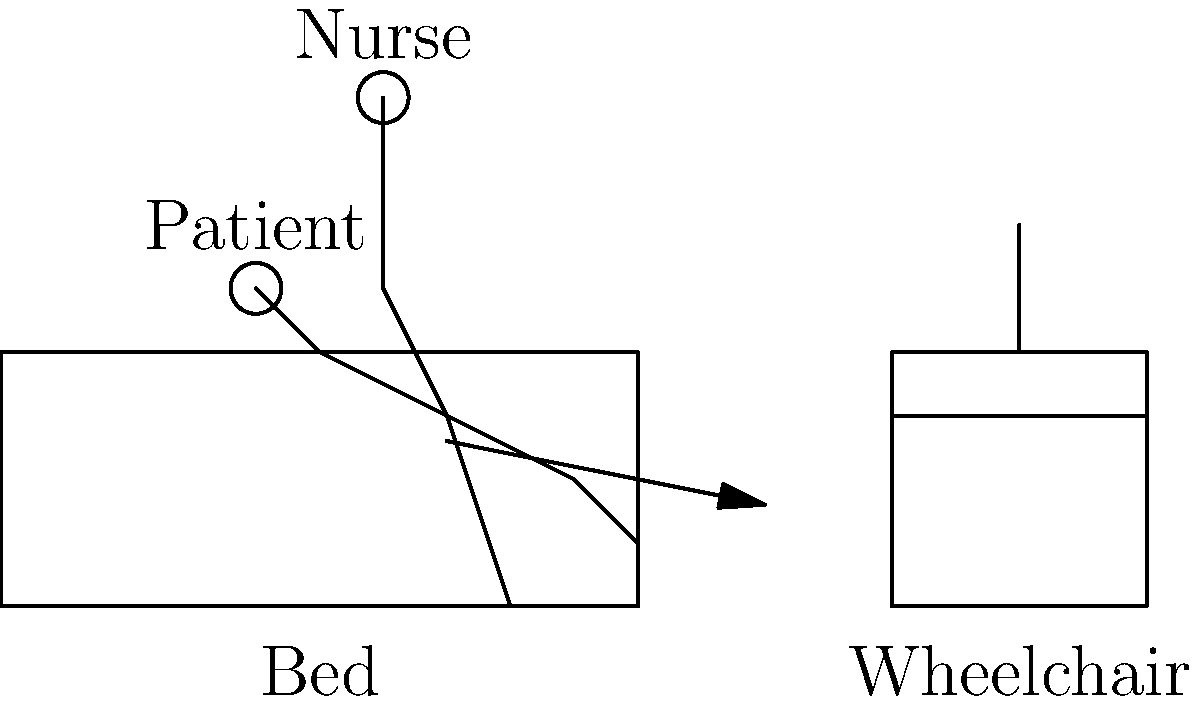In the diagram illustrating proper body mechanics for transferring a patient from bed to wheelchair, what is the primary reason for the nurse's bent knee posture? The proper body mechanics for transferring a patient from bed to wheelchair involve several key principles:

1. Stable base of support: The nurse's feet are positioned shoulder-width apart, providing a stable foundation.

2. Lowered center of gravity: The nurse's bent knee posture lowers their center of gravity, which is crucial for maintaining balance during the transfer.

3. Use of leg muscles: The bent knee position allows the nurse to use their stronger leg muscles (quadriceps and gluteal muscles) rather than relying on back muscles.

4. Spine alignment: The nurse's back is kept straight, maintaining proper spinal alignment to reduce the risk of injury.

5. Close proximity: The nurse is positioned close to the patient, minimizing the distance over which force needs to be applied.

6. Pivot technique: The bent knee position facilitates a smooth pivoting motion when turning to face the wheelchair.

7. Weight distribution: This posture allows for even distribution of the patient's weight across the nurse's body.

The primary reason for the nurse's bent knee posture is to utilize the stronger leg muscles for lifting and transferring the patient, reducing strain on the back and lowering the risk of injury. This posture is fundamental to safe patient handling techniques.
Answer: To use stronger leg muscles for lifting, reducing back strain 